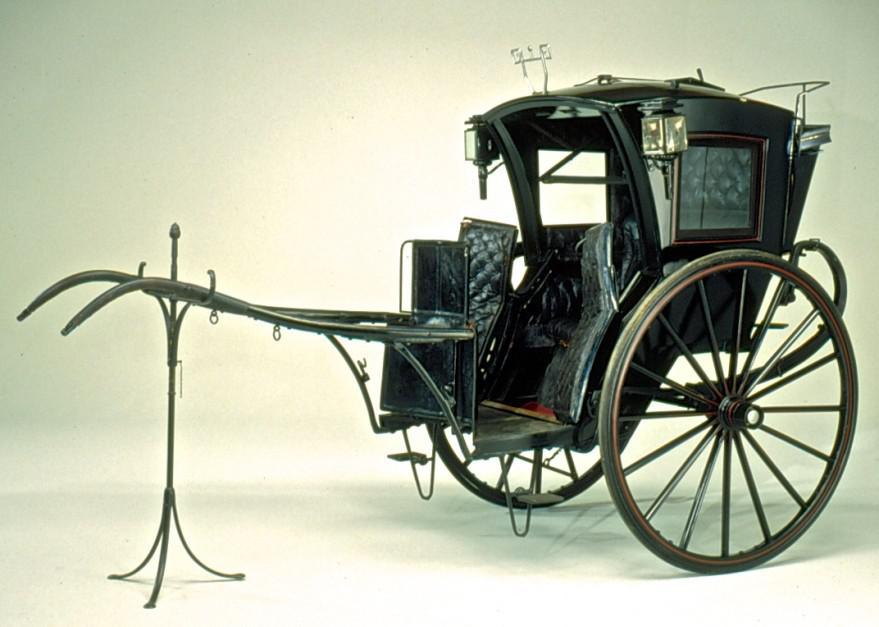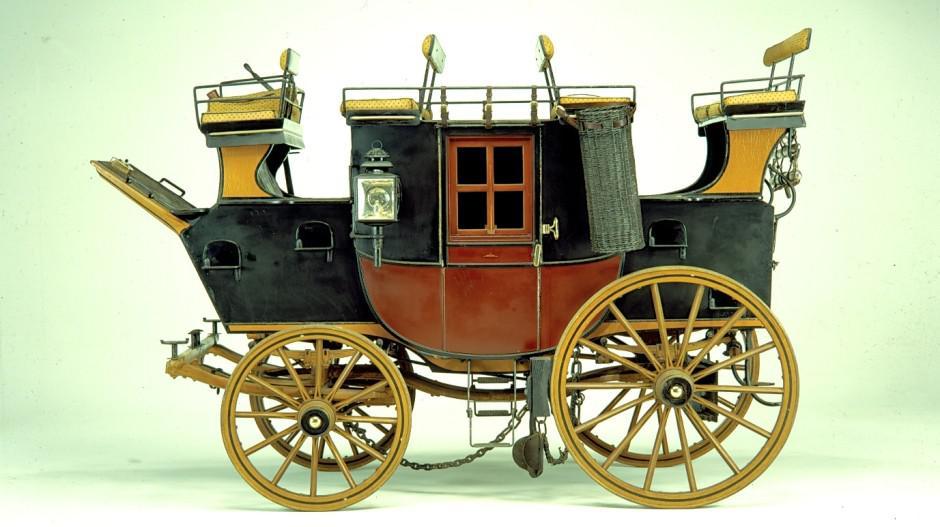The first image is the image on the left, the second image is the image on the right. Considering the images on both sides, is "One carriage driver is holding a whip." valid? Answer yes or no. No. The first image is the image on the left, the second image is the image on the right. Analyze the images presented: Is the assertion "The left and right image contains a total of two horses facing the opposite directions." valid? Answer yes or no. No. 